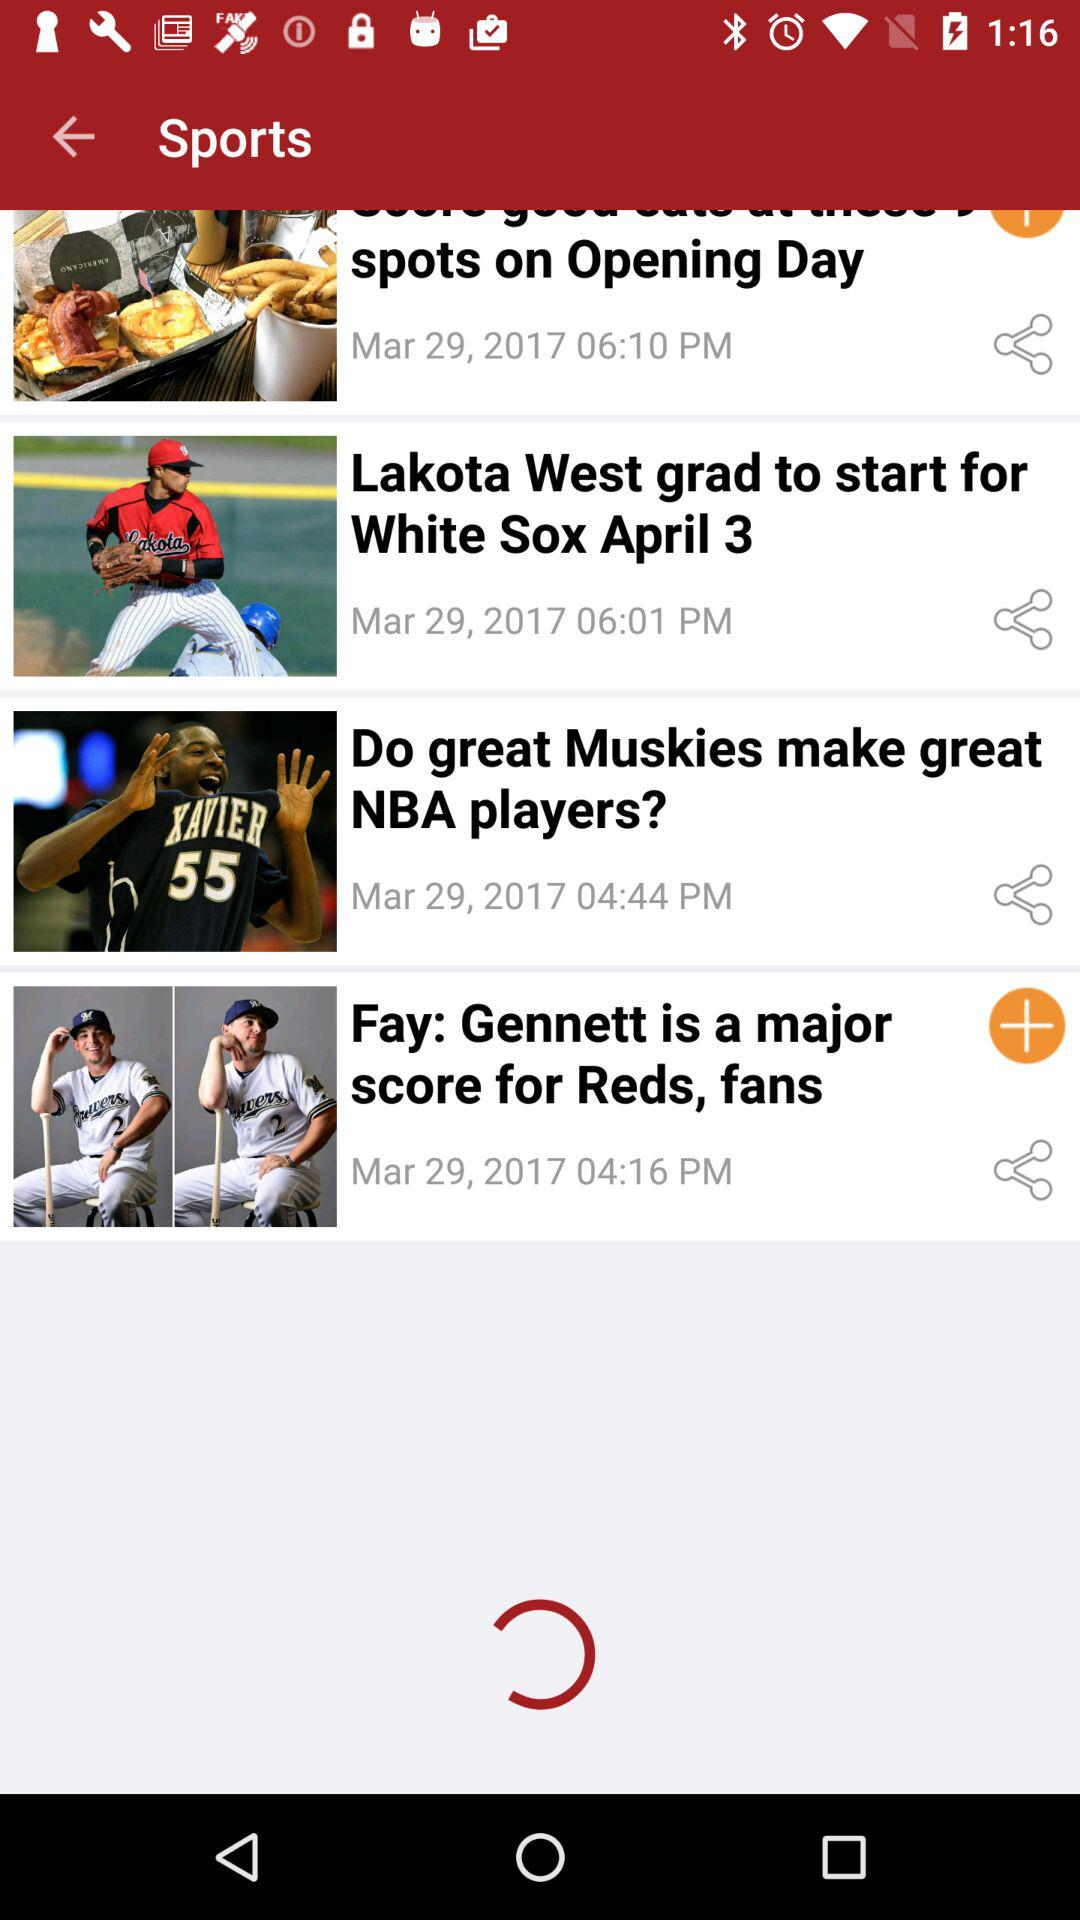When was "Do great Muskies make great NBA players?" posted? "Do great Muskies make great NBA players?" was posted on March 29, 2017 at 4:44 p.m. 